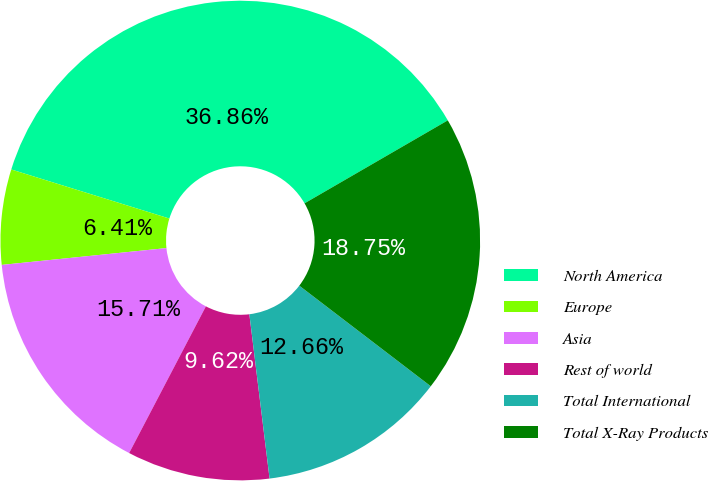<chart> <loc_0><loc_0><loc_500><loc_500><pie_chart><fcel>North America<fcel>Europe<fcel>Asia<fcel>Rest of world<fcel>Total International<fcel>Total X-Ray Products<nl><fcel>36.86%<fcel>6.41%<fcel>15.71%<fcel>9.62%<fcel>12.66%<fcel>18.75%<nl></chart> 